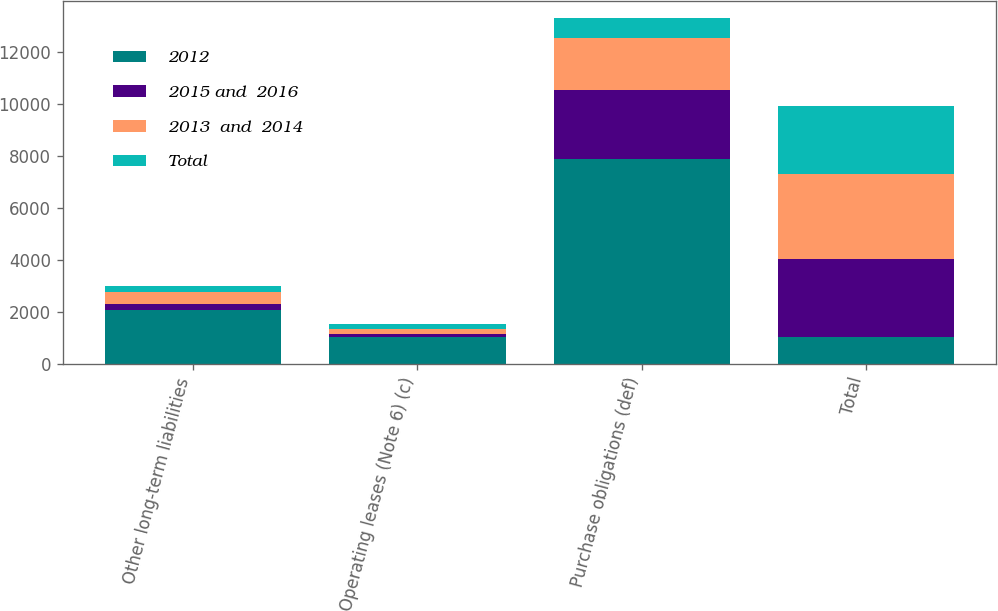<chart> <loc_0><loc_0><loc_500><loc_500><stacked_bar_chart><ecel><fcel>Other long-term liabilities<fcel>Operating leases (Note 6) (c)<fcel>Purchase obligations (def)<fcel>Total<nl><fcel>2012<fcel>2070<fcel>1013<fcel>7868<fcel>1013<nl><fcel>2015 and  2016<fcel>228<fcel>140<fcel>2657<fcel>3025<nl><fcel>2013  and  2014<fcel>459<fcel>187<fcel>2027<fcel>3273<nl><fcel>Total<fcel>222<fcel>169<fcel>759<fcel>2600<nl></chart> 